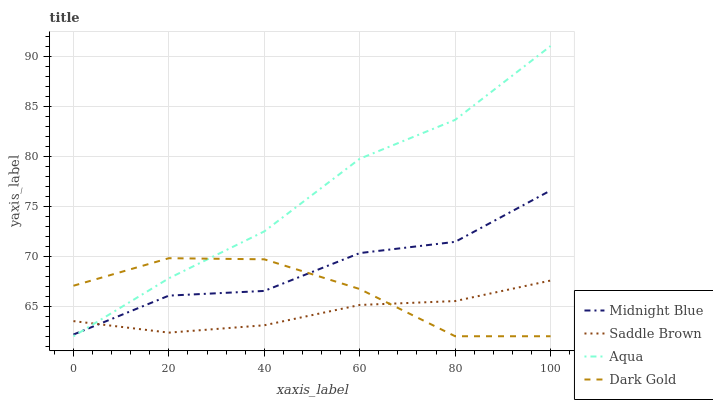Does Saddle Brown have the minimum area under the curve?
Answer yes or no. Yes. Does Aqua have the maximum area under the curve?
Answer yes or no. Yes. Does Midnight Blue have the minimum area under the curve?
Answer yes or no. No. Does Midnight Blue have the maximum area under the curve?
Answer yes or no. No. Is Saddle Brown the smoothest?
Answer yes or no. Yes. Is Midnight Blue the roughest?
Answer yes or no. Yes. Is Aqua the smoothest?
Answer yes or no. No. Is Aqua the roughest?
Answer yes or no. No. Does Midnight Blue have the lowest value?
Answer yes or no. No. Does Aqua have the highest value?
Answer yes or no. Yes. Does Midnight Blue have the highest value?
Answer yes or no. No. Does Midnight Blue intersect Saddle Brown?
Answer yes or no. Yes. Is Midnight Blue less than Saddle Brown?
Answer yes or no. No. Is Midnight Blue greater than Saddle Brown?
Answer yes or no. No. 